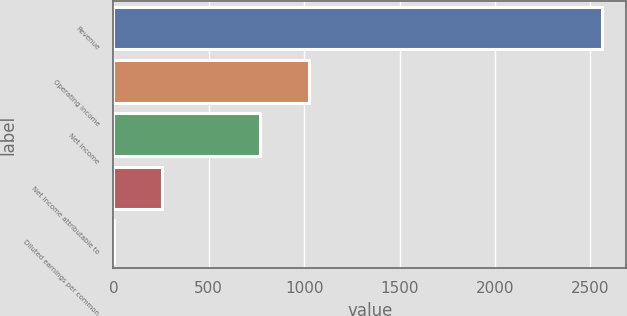Convert chart. <chart><loc_0><loc_0><loc_500><loc_500><bar_chart><fcel>Revenue<fcel>Operating income<fcel>Net income<fcel>Net income attributable to<fcel>Diluted earnings per common<nl><fcel>2562<fcel>1025.18<fcel>769.05<fcel>256.79<fcel>0.66<nl></chart> 